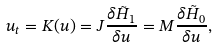Convert formula to latex. <formula><loc_0><loc_0><loc_500><loc_500>u _ { t } = K ( u ) = J \frac { \delta \tilde { H } _ { 1 } } { \delta u } = M \frac { \delta \tilde { H } _ { 0 } } { \delta u } ,</formula> 